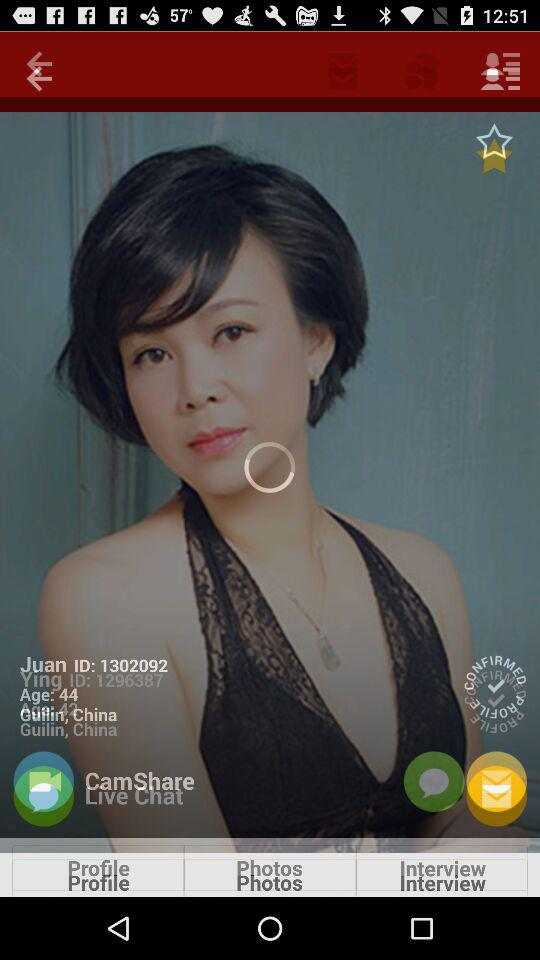What is the ID of Ying? The ID of Ying is 1296387. 